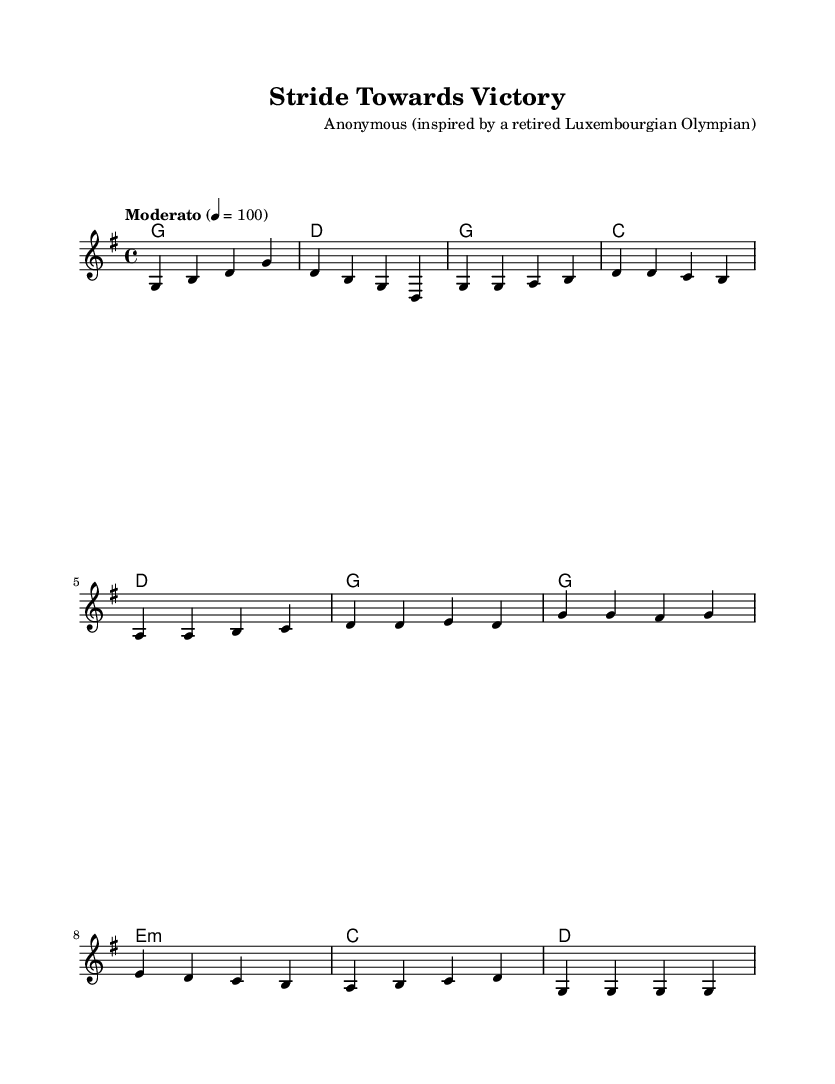What is the key signature of this music? The key signature is G major, depicted by one sharp (F#) in the key signature at the beginning of the staff.
Answer: G major What is the time signature of this music? The time signature is 4/4, which indicates that there are four beats in each measure and the quarter note gets one beat. This is shown at the beginning of the score near the clef.
Answer: 4/4 What is the tempo marking given in the music? The tempo marking is marked as "Moderato" with a metronome marking of quarter note equals 100, indicating a moderate speed for performance.
Answer: Moderato 100 How many measures are in the Verse? The Verse consists of 4 measures, which can be counted by looking at the notation of the melody and the corresponding lyrics.
Answer: 4 What is the first line of the chorus? The first line of the chorus reads "Stride towards victory," which can be found by examining the lyrics aligned with the notes in the melody section.
Answer: Stride towards victory How does the Chorus relate to themes of perseverance? The Chorus emphasizes perseverance through its lyrics "overcome adversity," which directly reflects the message of overcoming challenges and progressing towards one's goals.
Answer: Overcome adversity What emotion is conveyed by the final note in the melody? The final note is G, which resolves the melody on a strong and stable note, suggesting a feeling of triumph and completion after the journey of perseverance.
Answer: Triumph 